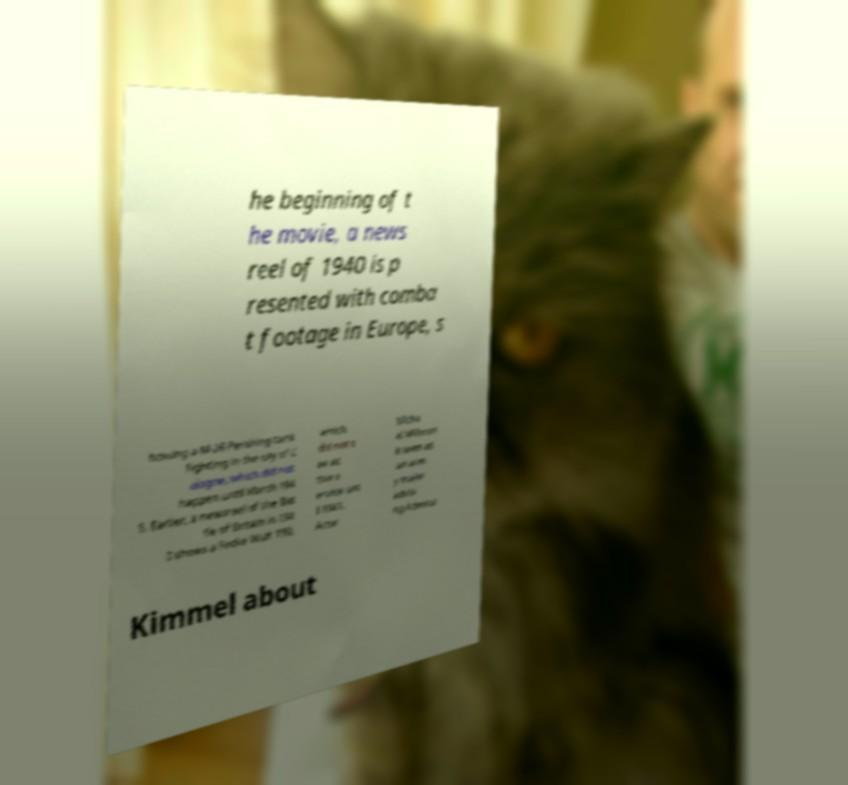Could you assist in decoding the text presented in this image and type it out clearly? he beginning of t he movie, a news reel of 1940 is p resented with comba t footage in Europe, s howing a M-26 Pershing tank fighting in the city of C ologne, which did not happen until March 194 5. Earlier, a newsreel of the Bat tle of Britain in 194 0 shows a Focke Wulf 190, which did not s ee ac tive s ervice unt il 1941. Actor Micha el Milhoan is seen as an arm y major advisi ng Admiral Kimmel about 